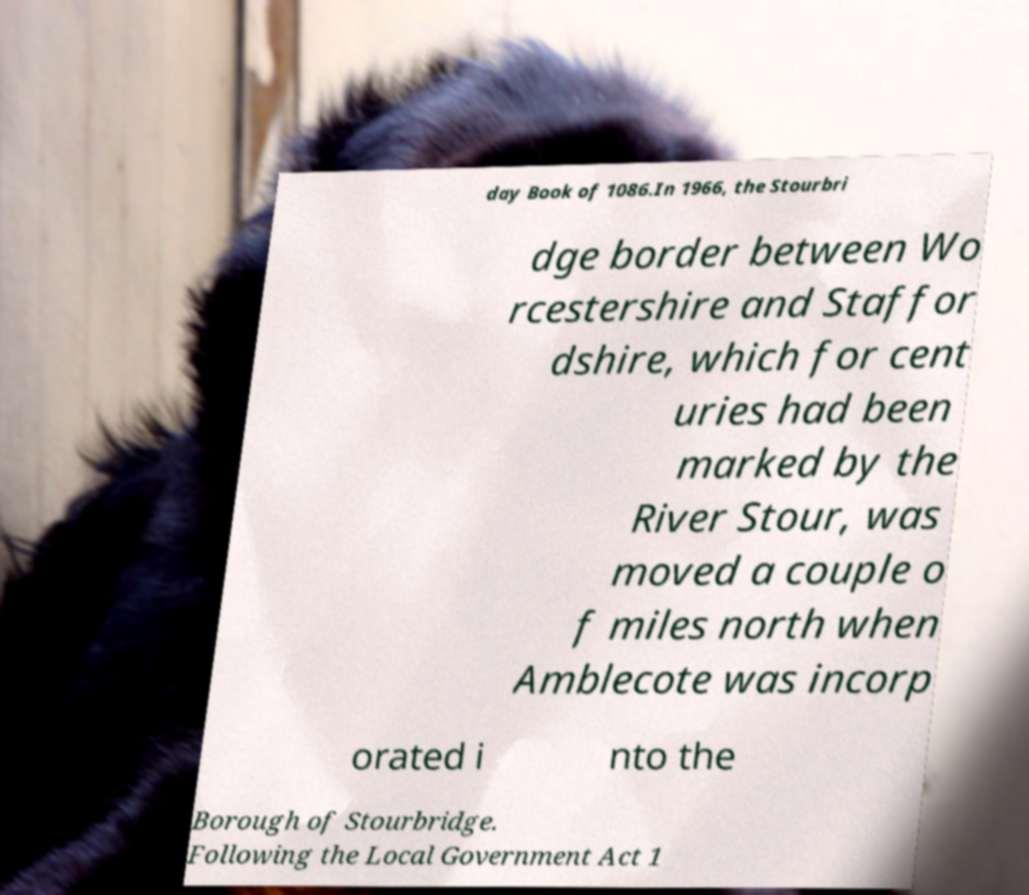Please read and relay the text visible in this image. What does it say? day Book of 1086.In 1966, the Stourbri dge border between Wo rcestershire and Staffor dshire, which for cent uries had been marked by the River Stour, was moved a couple o f miles north when Amblecote was incorp orated i nto the Borough of Stourbridge. Following the Local Government Act 1 